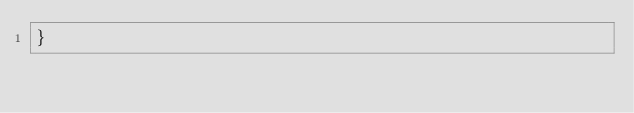<code> <loc_0><loc_0><loc_500><loc_500><_Scala_>}
</code> 